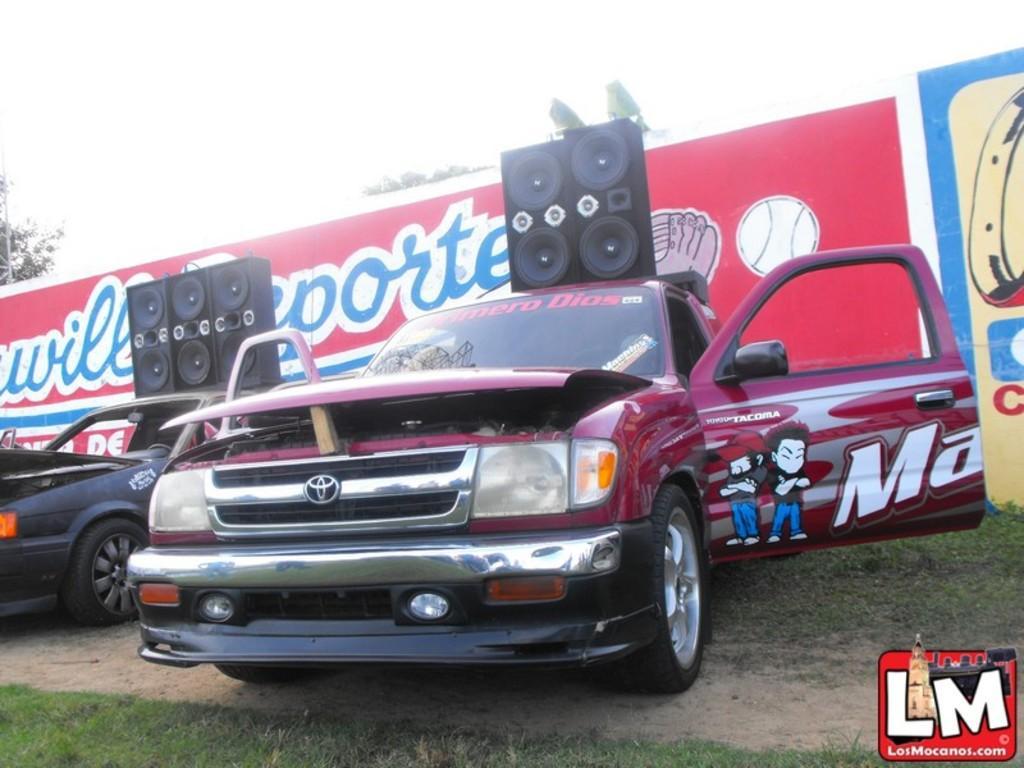Describe this image in one or two sentences. In this image we can see two cars with the sound boxes parked on the land. We can also see the grass. In the background, we can see the trees and also the painted wall with the text. At the top there is sky and in the bottom right corner we can see the logo. 